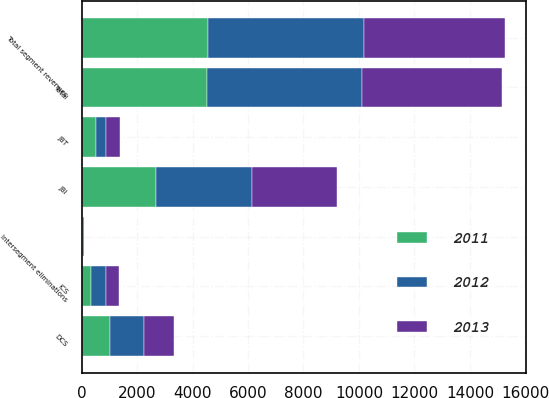Convert chart to OTSL. <chart><loc_0><loc_0><loc_500><loc_500><stacked_bar_chart><ecel><fcel>JBI<fcel>DCS<fcel>ICS<fcel>JBT<fcel>Total segment revenues<fcel>Intersegment eliminations<fcel>Total<nl><fcel>2012<fcel>3456<fcel>1231<fcel>537<fcel>391<fcel>5615<fcel>30<fcel>5585<nl><fcel>2013<fcel>3071<fcel>1080<fcel>456<fcel>484<fcel>5091<fcel>36<fcel>5055<nl><fcel>2011<fcel>2673<fcel>1031<fcel>356<fcel>504<fcel>4564<fcel>37<fcel>4527<nl></chart> 